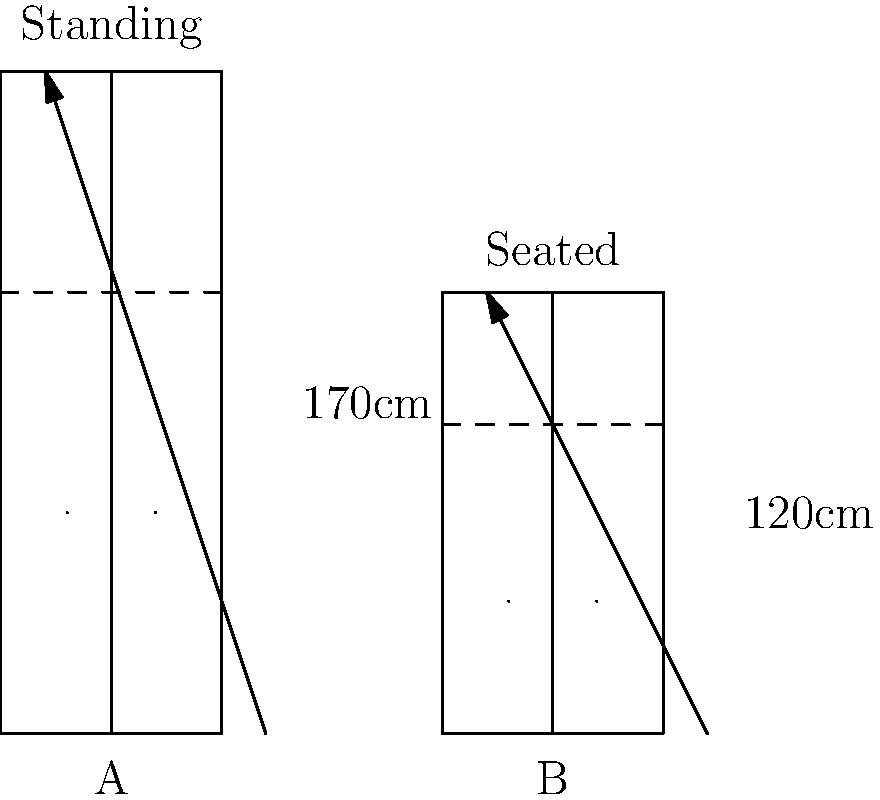Based on the ergonomic designs of voting booths shown in the diagram, which design (A or B) is likely to be more accessible and comfortable for a wider range of voters, and why? Consider factors such as physical accessibility, privacy, and potential impact on voter participation. To answer this question, we need to analyze the ergonomic features of both voting booth designs:

1. Design A (Standing Booth):
   - Height: 170cm
   - Requires voters to stand
   - Provides more vertical space for privacy

2. Design B (Seated Booth):
   - Height: 120cm
   - Allows voters to sit
   - Compact design with less vertical space

Step-by-step analysis:

1. Accessibility:
   - Design B is more accessible for people with mobility issues, elderly voters, and those who cannot stand for extended periods.
   - Design A may exclude or discourage participation from these groups.

2. Comfort:
   - Design B offers a seated position, which is generally more comfortable for longer voting processes.
   - Design A may cause fatigue for some voters, potentially rushing their decision-making.

3. Privacy:
   - Design A provides more vertical space, potentially offering better privacy.
   - Design B's lower height might compromise privacy, but this could be mitigated with proper side panels.

4. Space efficiency:
   - Design B is more compact, allowing for more voting booths in a given space.
   - This could reduce waiting times and potentially increase voter turnout.

5. Adaptability:
   - Design B can accommodate both standing and seated voters, making it more versatile.
   - Design A is limited to standing voters only.

6. Potential impact on voter participation:
   - Design B's accessibility and comfort features may encourage higher participation rates, especially among elderly or disabled voters.
   - Design A might inadvertently suppress turnout among certain demographic groups.

Considering these factors, Design B (Seated Booth) is likely to be more accessible and comfortable for a wider range of voters. It addresses physical accessibility concerns, potentially increases comfort during the voting process, and could positively impact voter participation rates. While privacy might be slightly compromised, this can be addressed through additional design features.
Answer: Design B (Seated Booth) - more accessible, comfortable, and likely to increase voter participation across diverse demographics. 